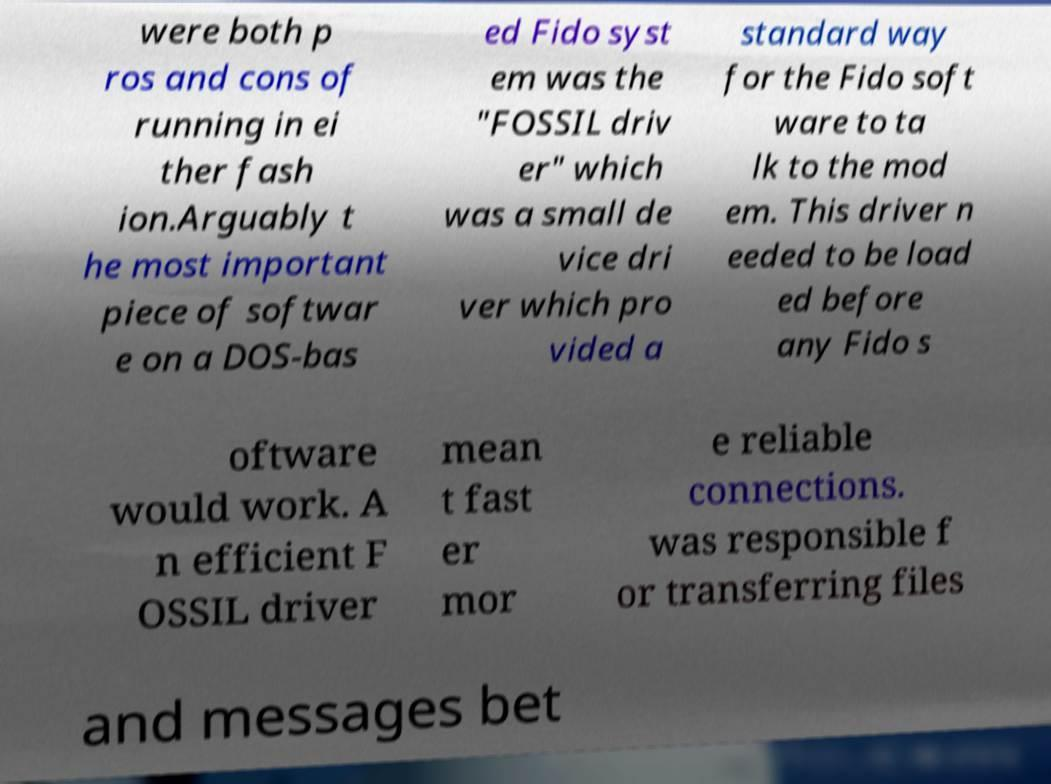I need the written content from this picture converted into text. Can you do that? were both p ros and cons of running in ei ther fash ion.Arguably t he most important piece of softwar e on a DOS-bas ed Fido syst em was the "FOSSIL driv er" which was a small de vice dri ver which pro vided a standard way for the Fido soft ware to ta lk to the mod em. This driver n eeded to be load ed before any Fido s oftware would work. A n efficient F OSSIL driver mean t fast er mor e reliable connections. was responsible f or transferring files and messages bet 